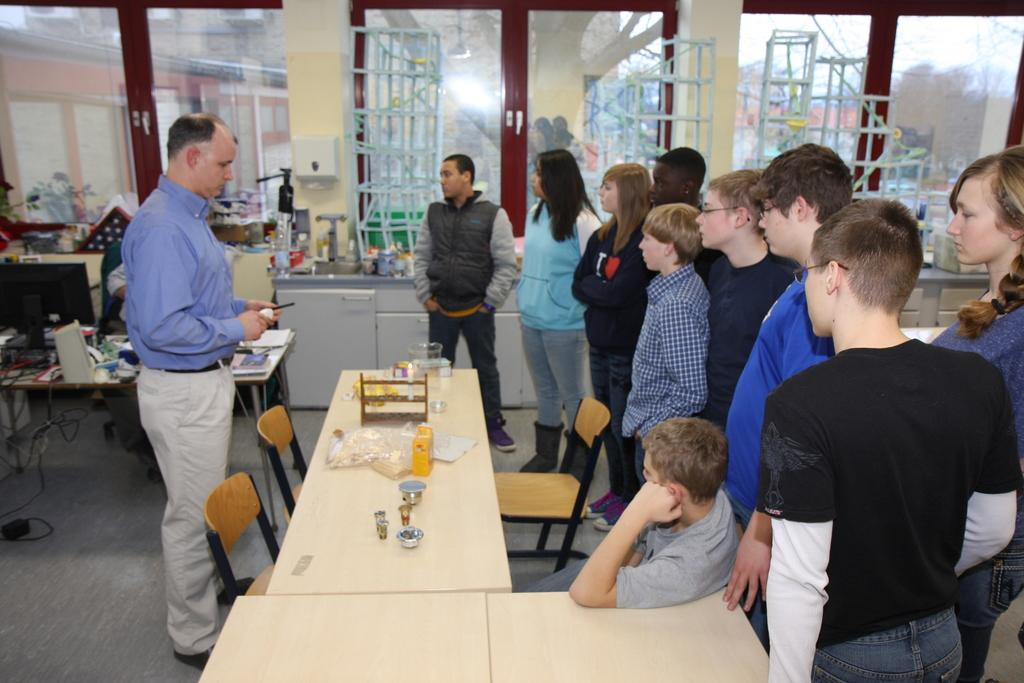What is the main object in the center of the image? There is a table in the center of the image. What items can be seen on the table? Glasses and covers are on the table. Where are the people located in the image? There are people standing at the left side and the right side of the image. What is visible at the back of the image? There is a window at the back of the image. What type of pollution can be seen coming from the window in the image? There is no pollution visible in the image, as it only features a table, glasses, covers, and people standing nearby. Is there any jam on the table in the image? There is no jam present on the table in the image. 